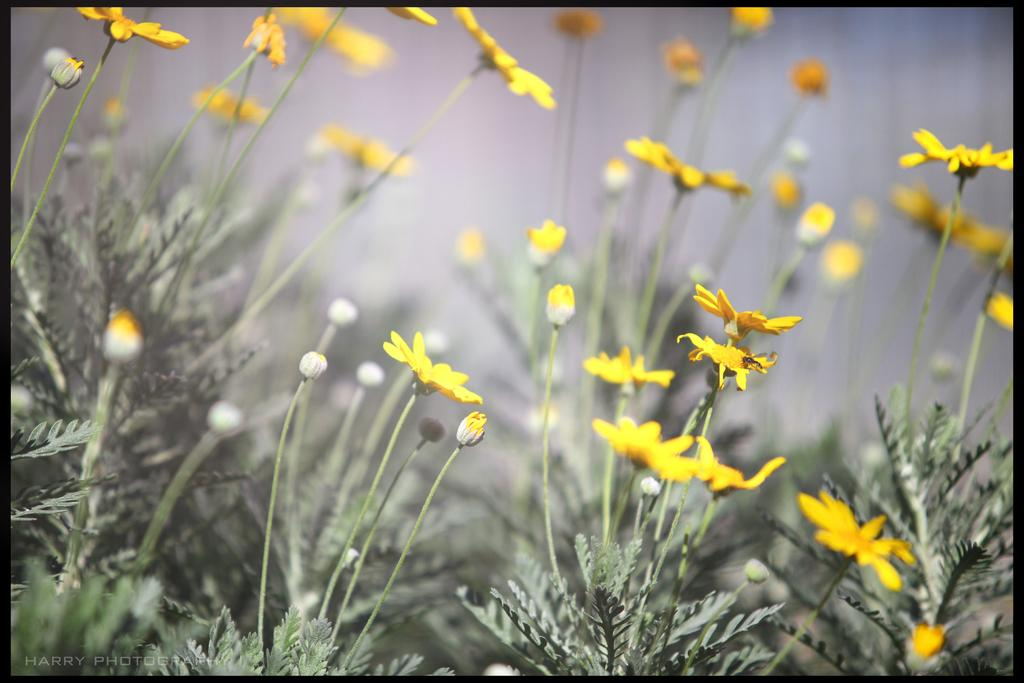What type of flowers can be seen in the image? There are yellow flowers in the image. What else is visible at the bottom of the image? There are leaves at the bottom of the image. What type of flag is being waved in the image? There is no flag present in the image; it only features yellow flowers and leaves. What impulse might cause the flowers to grow in the image? The image does not provide information about the growth of the flowers or any impulses that might affect them. 